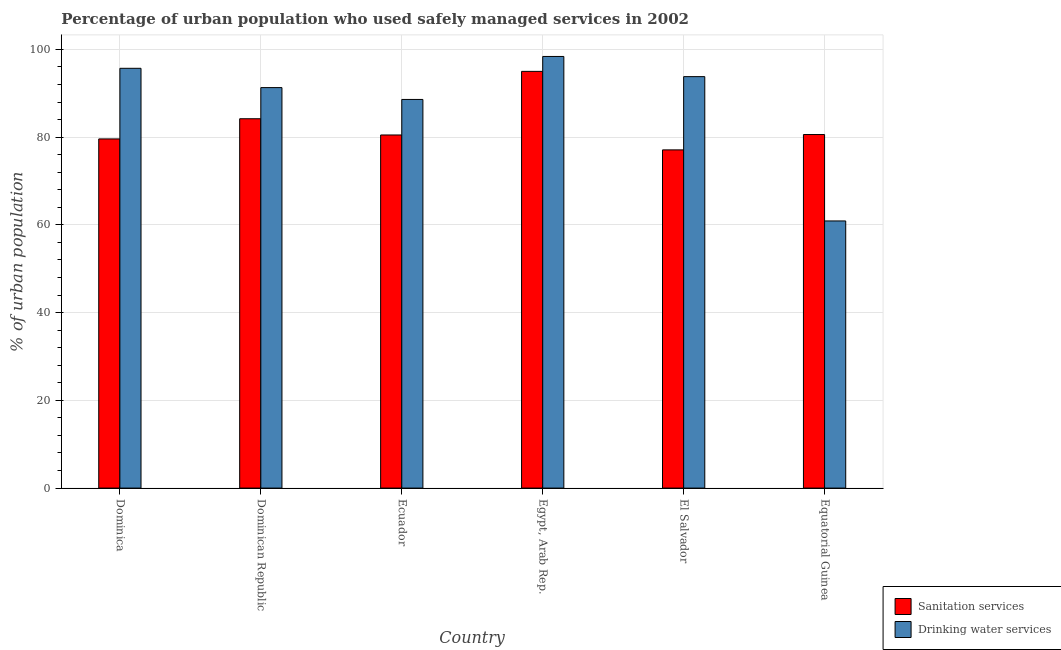How many different coloured bars are there?
Provide a succinct answer. 2. Are the number of bars on each tick of the X-axis equal?
Your answer should be compact. Yes. How many bars are there on the 5th tick from the right?
Your answer should be compact. 2. What is the label of the 2nd group of bars from the left?
Your answer should be compact. Dominican Republic. In how many cases, is the number of bars for a given country not equal to the number of legend labels?
Make the answer very short. 0. What is the percentage of urban population who used drinking water services in Dominica?
Offer a terse response. 95.7. Across all countries, what is the maximum percentage of urban population who used drinking water services?
Make the answer very short. 98.4. Across all countries, what is the minimum percentage of urban population who used drinking water services?
Keep it short and to the point. 60.9. In which country was the percentage of urban population who used drinking water services maximum?
Provide a short and direct response. Egypt, Arab Rep. In which country was the percentage of urban population who used sanitation services minimum?
Your answer should be compact. El Salvador. What is the total percentage of urban population who used drinking water services in the graph?
Provide a short and direct response. 528.7. What is the difference between the percentage of urban population who used drinking water services in Egypt, Arab Rep. and that in El Salvador?
Keep it short and to the point. 4.6. What is the difference between the percentage of urban population who used sanitation services in El Salvador and the percentage of urban population who used drinking water services in Egypt, Arab Rep.?
Give a very brief answer. -21.3. What is the average percentage of urban population who used sanitation services per country?
Your answer should be compact. 82.83. What is the difference between the percentage of urban population who used sanitation services and percentage of urban population who used drinking water services in Egypt, Arab Rep.?
Give a very brief answer. -3.4. In how many countries, is the percentage of urban population who used sanitation services greater than 64 %?
Offer a very short reply. 6. What is the ratio of the percentage of urban population who used drinking water services in Dominican Republic to that in Ecuador?
Make the answer very short. 1.03. Is the difference between the percentage of urban population who used sanitation services in Dominican Republic and Ecuador greater than the difference between the percentage of urban population who used drinking water services in Dominican Republic and Ecuador?
Keep it short and to the point. Yes. What is the difference between the highest and the second highest percentage of urban population who used sanitation services?
Your answer should be compact. 10.8. What is the difference between the highest and the lowest percentage of urban population who used drinking water services?
Offer a very short reply. 37.5. Is the sum of the percentage of urban population who used sanitation services in Egypt, Arab Rep. and Equatorial Guinea greater than the maximum percentage of urban population who used drinking water services across all countries?
Keep it short and to the point. Yes. What does the 2nd bar from the left in El Salvador represents?
Offer a very short reply. Drinking water services. What does the 1st bar from the right in Dominican Republic represents?
Provide a short and direct response. Drinking water services. How many bars are there?
Your response must be concise. 12. Are all the bars in the graph horizontal?
Offer a terse response. No. How many countries are there in the graph?
Your answer should be compact. 6. Does the graph contain grids?
Offer a terse response. Yes. Where does the legend appear in the graph?
Provide a short and direct response. Bottom right. What is the title of the graph?
Provide a succinct answer. Percentage of urban population who used safely managed services in 2002. Does "Electricity" appear as one of the legend labels in the graph?
Keep it short and to the point. No. What is the label or title of the X-axis?
Ensure brevity in your answer.  Country. What is the label or title of the Y-axis?
Your response must be concise. % of urban population. What is the % of urban population in Sanitation services in Dominica?
Offer a terse response. 79.6. What is the % of urban population of Drinking water services in Dominica?
Provide a succinct answer. 95.7. What is the % of urban population of Sanitation services in Dominican Republic?
Keep it short and to the point. 84.2. What is the % of urban population of Drinking water services in Dominican Republic?
Provide a short and direct response. 91.3. What is the % of urban population in Sanitation services in Ecuador?
Provide a short and direct response. 80.5. What is the % of urban population of Drinking water services in Ecuador?
Ensure brevity in your answer.  88.6. What is the % of urban population of Drinking water services in Egypt, Arab Rep.?
Your answer should be compact. 98.4. What is the % of urban population of Sanitation services in El Salvador?
Keep it short and to the point. 77.1. What is the % of urban population in Drinking water services in El Salvador?
Offer a terse response. 93.8. What is the % of urban population in Sanitation services in Equatorial Guinea?
Your response must be concise. 80.6. What is the % of urban population in Drinking water services in Equatorial Guinea?
Your answer should be compact. 60.9. Across all countries, what is the maximum % of urban population in Drinking water services?
Make the answer very short. 98.4. Across all countries, what is the minimum % of urban population of Sanitation services?
Your response must be concise. 77.1. Across all countries, what is the minimum % of urban population in Drinking water services?
Provide a short and direct response. 60.9. What is the total % of urban population in Sanitation services in the graph?
Keep it short and to the point. 497. What is the total % of urban population in Drinking water services in the graph?
Make the answer very short. 528.7. What is the difference between the % of urban population in Sanitation services in Dominica and that in Dominican Republic?
Provide a short and direct response. -4.6. What is the difference between the % of urban population in Sanitation services in Dominica and that in Ecuador?
Keep it short and to the point. -0.9. What is the difference between the % of urban population in Drinking water services in Dominica and that in Ecuador?
Offer a very short reply. 7.1. What is the difference between the % of urban population of Sanitation services in Dominica and that in Egypt, Arab Rep.?
Your answer should be very brief. -15.4. What is the difference between the % of urban population of Drinking water services in Dominica and that in Egypt, Arab Rep.?
Provide a succinct answer. -2.7. What is the difference between the % of urban population in Sanitation services in Dominica and that in El Salvador?
Offer a terse response. 2.5. What is the difference between the % of urban population in Sanitation services in Dominica and that in Equatorial Guinea?
Your response must be concise. -1. What is the difference between the % of urban population of Drinking water services in Dominica and that in Equatorial Guinea?
Provide a short and direct response. 34.8. What is the difference between the % of urban population in Sanitation services in Dominican Republic and that in Ecuador?
Provide a short and direct response. 3.7. What is the difference between the % of urban population of Sanitation services in Dominican Republic and that in El Salvador?
Offer a terse response. 7.1. What is the difference between the % of urban population of Drinking water services in Dominican Republic and that in El Salvador?
Provide a succinct answer. -2.5. What is the difference between the % of urban population in Drinking water services in Dominican Republic and that in Equatorial Guinea?
Ensure brevity in your answer.  30.4. What is the difference between the % of urban population in Sanitation services in Ecuador and that in Egypt, Arab Rep.?
Keep it short and to the point. -14.5. What is the difference between the % of urban population in Drinking water services in Ecuador and that in Egypt, Arab Rep.?
Your answer should be compact. -9.8. What is the difference between the % of urban population in Drinking water services in Ecuador and that in El Salvador?
Your answer should be compact. -5.2. What is the difference between the % of urban population of Drinking water services in Ecuador and that in Equatorial Guinea?
Your answer should be compact. 27.7. What is the difference between the % of urban population of Drinking water services in Egypt, Arab Rep. and that in El Salvador?
Offer a terse response. 4.6. What is the difference between the % of urban population of Drinking water services in Egypt, Arab Rep. and that in Equatorial Guinea?
Your answer should be very brief. 37.5. What is the difference between the % of urban population of Drinking water services in El Salvador and that in Equatorial Guinea?
Ensure brevity in your answer.  32.9. What is the difference between the % of urban population of Sanitation services in Dominica and the % of urban population of Drinking water services in Egypt, Arab Rep.?
Offer a very short reply. -18.8. What is the difference between the % of urban population in Sanitation services in Dominica and the % of urban population in Drinking water services in El Salvador?
Provide a succinct answer. -14.2. What is the difference between the % of urban population of Sanitation services in Dominican Republic and the % of urban population of Drinking water services in Egypt, Arab Rep.?
Make the answer very short. -14.2. What is the difference between the % of urban population of Sanitation services in Dominican Republic and the % of urban population of Drinking water services in El Salvador?
Keep it short and to the point. -9.6. What is the difference between the % of urban population in Sanitation services in Dominican Republic and the % of urban population in Drinking water services in Equatorial Guinea?
Your answer should be very brief. 23.3. What is the difference between the % of urban population of Sanitation services in Ecuador and the % of urban population of Drinking water services in Egypt, Arab Rep.?
Provide a succinct answer. -17.9. What is the difference between the % of urban population in Sanitation services in Ecuador and the % of urban population in Drinking water services in Equatorial Guinea?
Provide a succinct answer. 19.6. What is the difference between the % of urban population in Sanitation services in Egypt, Arab Rep. and the % of urban population in Drinking water services in Equatorial Guinea?
Your answer should be very brief. 34.1. What is the difference between the % of urban population in Sanitation services in El Salvador and the % of urban population in Drinking water services in Equatorial Guinea?
Ensure brevity in your answer.  16.2. What is the average % of urban population of Sanitation services per country?
Provide a succinct answer. 82.83. What is the average % of urban population of Drinking water services per country?
Offer a very short reply. 88.12. What is the difference between the % of urban population in Sanitation services and % of urban population in Drinking water services in Dominica?
Your answer should be compact. -16.1. What is the difference between the % of urban population of Sanitation services and % of urban population of Drinking water services in Ecuador?
Ensure brevity in your answer.  -8.1. What is the difference between the % of urban population in Sanitation services and % of urban population in Drinking water services in El Salvador?
Your answer should be compact. -16.7. What is the ratio of the % of urban population of Sanitation services in Dominica to that in Dominican Republic?
Keep it short and to the point. 0.95. What is the ratio of the % of urban population of Drinking water services in Dominica to that in Dominican Republic?
Give a very brief answer. 1.05. What is the ratio of the % of urban population of Drinking water services in Dominica to that in Ecuador?
Your answer should be compact. 1.08. What is the ratio of the % of urban population in Sanitation services in Dominica to that in Egypt, Arab Rep.?
Offer a terse response. 0.84. What is the ratio of the % of urban population of Drinking water services in Dominica to that in Egypt, Arab Rep.?
Your answer should be very brief. 0.97. What is the ratio of the % of urban population of Sanitation services in Dominica to that in El Salvador?
Offer a very short reply. 1.03. What is the ratio of the % of urban population of Drinking water services in Dominica to that in El Salvador?
Make the answer very short. 1.02. What is the ratio of the % of urban population of Sanitation services in Dominica to that in Equatorial Guinea?
Ensure brevity in your answer.  0.99. What is the ratio of the % of urban population of Drinking water services in Dominica to that in Equatorial Guinea?
Your answer should be compact. 1.57. What is the ratio of the % of urban population in Sanitation services in Dominican Republic to that in Ecuador?
Keep it short and to the point. 1.05. What is the ratio of the % of urban population in Drinking water services in Dominican Republic to that in Ecuador?
Offer a very short reply. 1.03. What is the ratio of the % of urban population of Sanitation services in Dominican Republic to that in Egypt, Arab Rep.?
Offer a very short reply. 0.89. What is the ratio of the % of urban population in Drinking water services in Dominican Republic to that in Egypt, Arab Rep.?
Keep it short and to the point. 0.93. What is the ratio of the % of urban population of Sanitation services in Dominican Republic to that in El Salvador?
Your response must be concise. 1.09. What is the ratio of the % of urban population in Drinking water services in Dominican Republic to that in El Salvador?
Offer a very short reply. 0.97. What is the ratio of the % of urban population in Sanitation services in Dominican Republic to that in Equatorial Guinea?
Keep it short and to the point. 1.04. What is the ratio of the % of urban population of Drinking water services in Dominican Republic to that in Equatorial Guinea?
Provide a succinct answer. 1.5. What is the ratio of the % of urban population of Sanitation services in Ecuador to that in Egypt, Arab Rep.?
Make the answer very short. 0.85. What is the ratio of the % of urban population of Drinking water services in Ecuador to that in Egypt, Arab Rep.?
Offer a terse response. 0.9. What is the ratio of the % of urban population in Sanitation services in Ecuador to that in El Salvador?
Your answer should be very brief. 1.04. What is the ratio of the % of urban population of Drinking water services in Ecuador to that in El Salvador?
Your response must be concise. 0.94. What is the ratio of the % of urban population of Sanitation services in Ecuador to that in Equatorial Guinea?
Provide a succinct answer. 1. What is the ratio of the % of urban population of Drinking water services in Ecuador to that in Equatorial Guinea?
Provide a short and direct response. 1.45. What is the ratio of the % of urban population of Sanitation services in Egypt, Arab Rep. to that in El Salvador?
Offer a very short reply. 1.23. What is the ratio of the % of urban population in Drinking water services in Egypt, Arab Rep. to that in El Salvador?
Offer a terse response. 1.05. What is the ratio of the % of urban population of Sanitation services in Egypt, Arab Rep. to that in Equatorial Guinea?
Offer a terse response. 1.18. What is the ratio of the % of urban population of Drinking water services in Egypt, Arab Rep. to that in Equatorial Guinea?
Your answer should be very brief. 1.62. What is the ratio of the % of urban population of Sanitation services in El Salvador to that in Equatorial Guinea?
Your answer should be compact. 0.96. What is the ratio of the % of urban population of Drinking water services in El Salvador to that in Equatorial Guinea?
Give a very brief answer. 1.54. What is the difference between the highest and the second highest % of urban population in Drinking water services?
Provide a short and direct response. 2.7. What is the difference between the highest and the lowest % of urban population of Sanitation services?
Make the answer very short. 17.9. What is the difference between the highest and the lowest % of urban population of Drinking water services?
Your answer should be very brief. 37.5. 